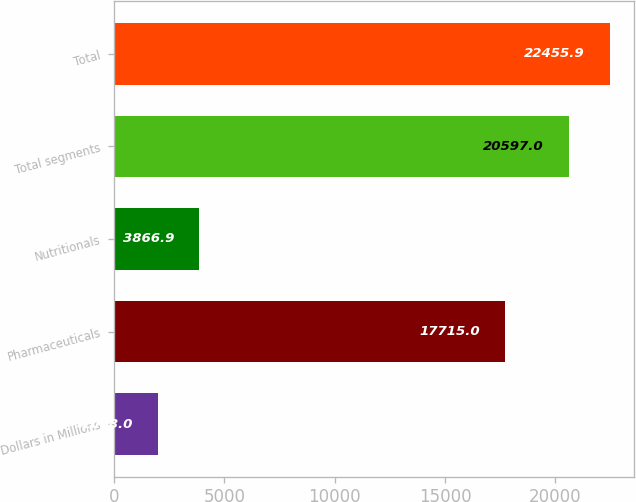Convert chart to OTSL. <chart><loc_0><loc_0><loc_500><loc_500><bar_chart><fcel>Dollars in Millions<fcel>Pharmaceuticals<fcel>Nutritionals<fcel>Total segments<fcel>Total<nl><fcel>2008<fcel>17715<fcel>3866.9<fcel>20597<fcel>22455.9<nl></chart> 